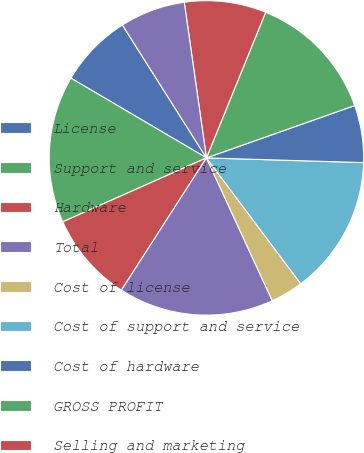Convert chart to OTSL. <chart><loc_0><loc_0><loc_500><loc_500><pie_chart><fcel>License<fcel>Support and service<fcel>Hardware<fcel>Total<fcel>Cost of license<fcel>Cost of support and service<fcel>Cost of hardware<fcel>GROSS PROFIT<fcel>Selling and marketing<fcel>Research and development<nl><fcel>7.56%<fcel>15.13%<fcel>9.24%<fcel>15.97%<fcel>3.36%<fcel>14.29%<fcel>5.88%<fcel>13.45%<fcel>8.4%<fcel>6.72%<nl></chart> 